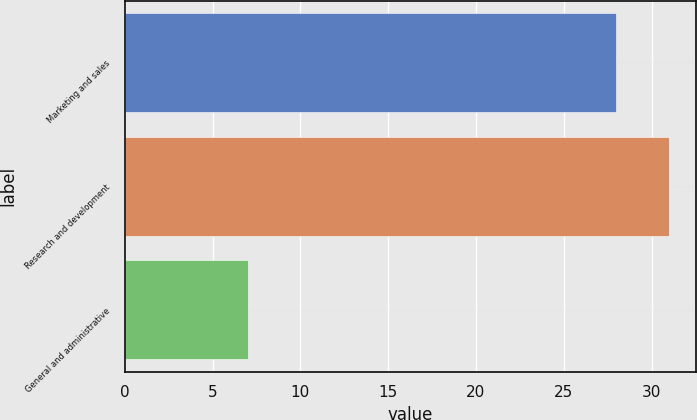Convert chart to OTSL. <chart><loc_0><loc_0><loc_500><loc_500><bar_chart><fcel>Marketing and sales<fcel>Research and development<fcel>General and administrative<nl><fcel>28<fcel>31<fcel>7<nl></chart> 